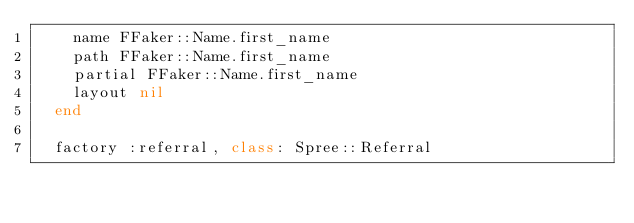Convert code to text. <code><loc_0><loc_0><loc_500><loc_500><_Ruby_>    name FFaker::Name.first_name
    path FFaker::Name.first_name
    partial FFaker::Name.first_name
    layout nil
  end

  factory :referral, class: Spree::Referral</code> 